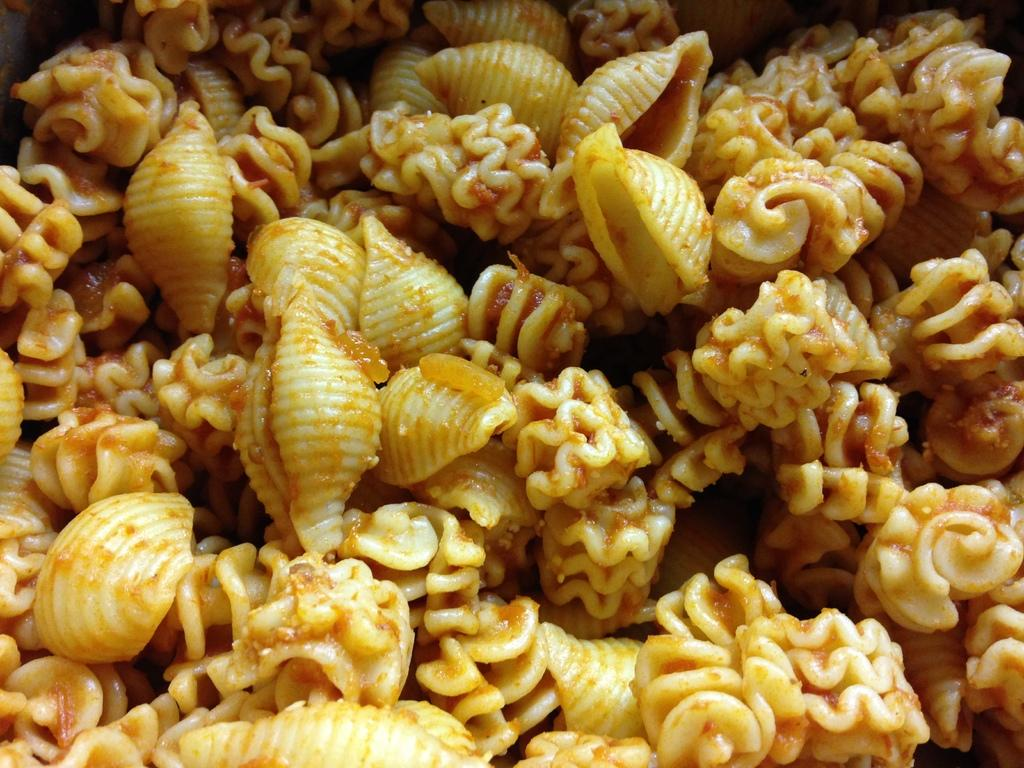What is present in the image related to food? There is food in the image. What type of chess piece can be seen on the plate in the image? There is no chess piece present on the plate or in the image; it only features food. 